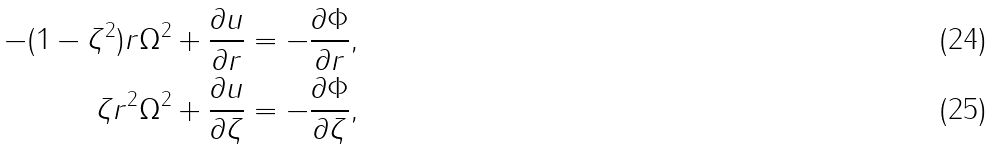<formula> <loc_0><loc_0><loc_500><loc_500>- ( 1 - \zeta ^ { 2 } ) r \Omega ^ { 2 } + \frac { \partial u } { \partial r } & = - \frac { \partial \Phi } { \partial r } , \\ \zeta r ^ { 2 } \Omega ^ { 2 } + \frac { \partial u } { \partial \zeta } & = - \frac { \partial \Phi } { \partial \zeta } ,</formula> 